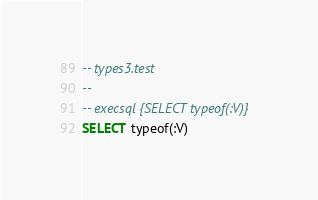<code> <loc_0><loc_0><loc_500><loc_500><_SQL_>-- types3.test
-- 
-- execsql {SELECT typeof(:V)}
SELECT typeof(:V)</code> 